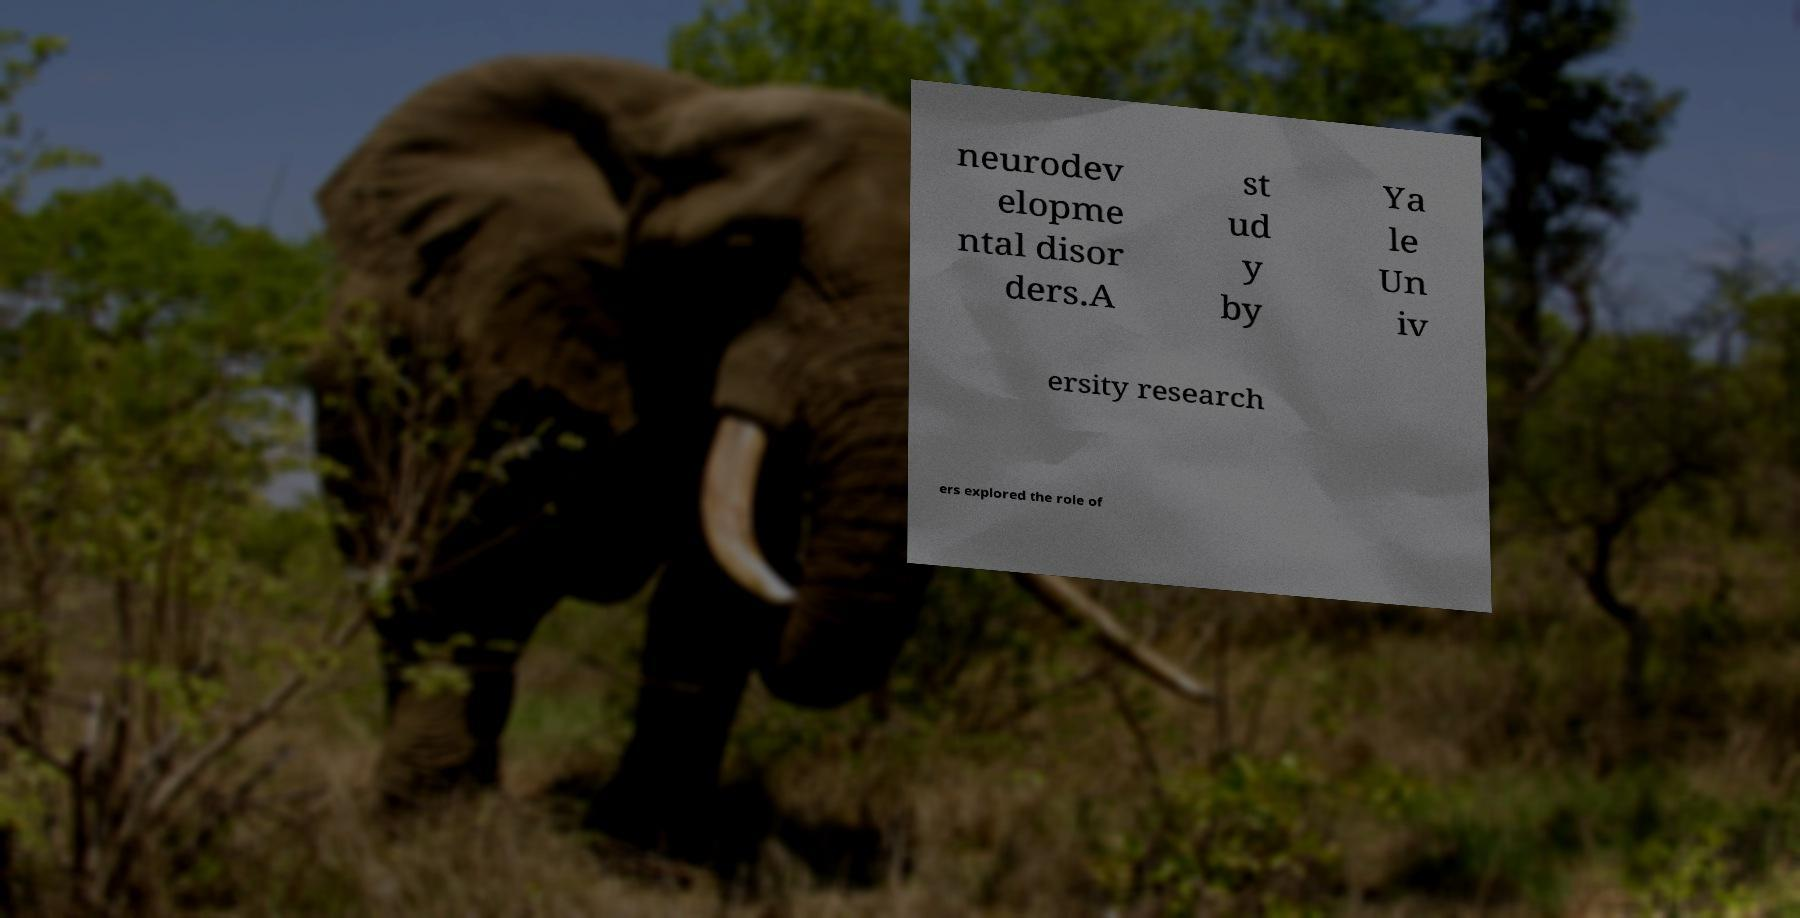Can you accurately transcribe the text from the provided image for me? neurodev elopme ntal disor ders.A st ud y by Ya le Un iv ersity research ers explored the role of 